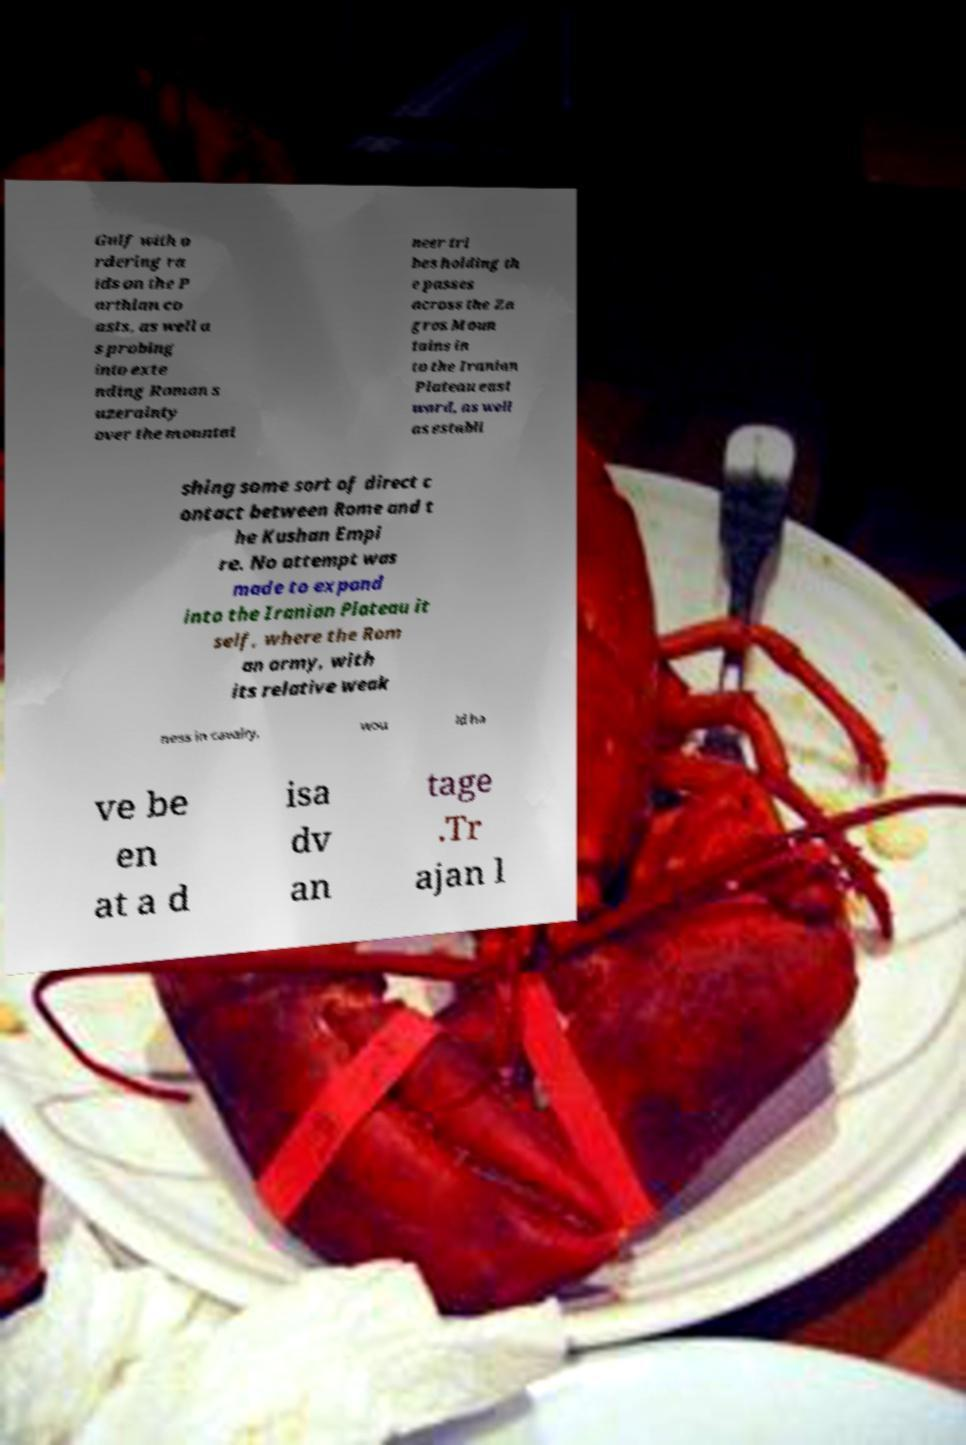Could you extract and type out the text from this image? Gulf with o rdering ra ids on the P arthian co asts, as well a s probing into exte nding Roman s uzerainty over the mountai neer tri bes holding th e passes across the Za gros Moun tains in to the Iranian Plateau east ward, as well as establi shing some sort of direct c ontact between Rome and t he Kushan Empi re. No attempt was made to expand into the Iranian Plateau it self, where the Rom an army, with its relative weak ness in cavalry, wou ld ha ve be en at a d isa dv an tage .Tr ajan l 